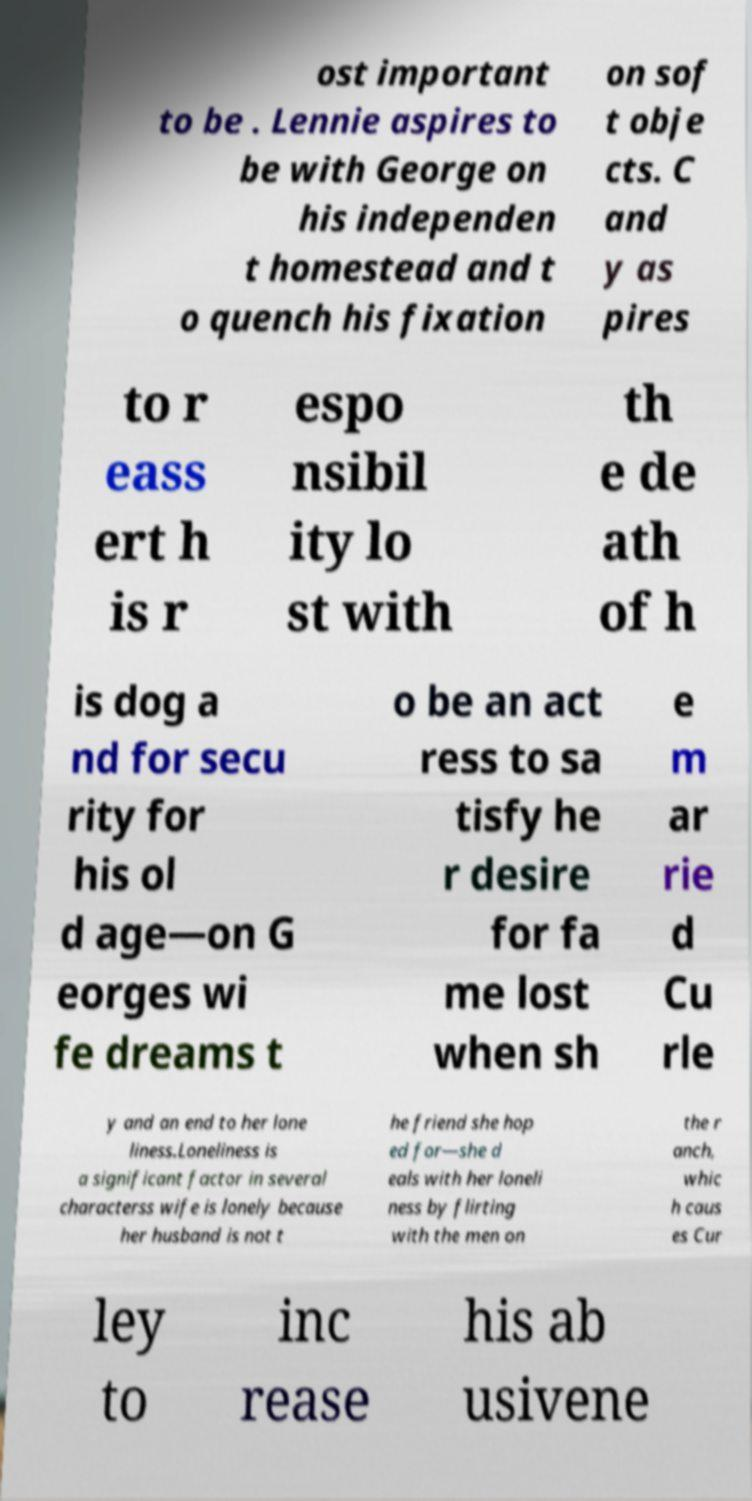What messages or text are displayed in this image? I need them in a readable, typed format. ost important to be . Lennie aspires to be with George on his independen t homestead and t o quench his fixation on sof t obje cts. C and y as pires to r eass ert h is r espo nsibil ity lo st with th e de ath of h is dog a nd for secu rity for his ol d age—on G eorges wi fe dreams t o be an act ress to sa tisfy he r desire for fa me lost when sh e m ar rie d Cu rle y and an end to her lone liness.Loneliness is a significant factor in several characterss wife is lonely because her husband is not t he friend she hop ed for—she d eals with her loneli ness by flirting with the men on the r anch, whic h caus es Cur ley to inc rease his ab usivene 